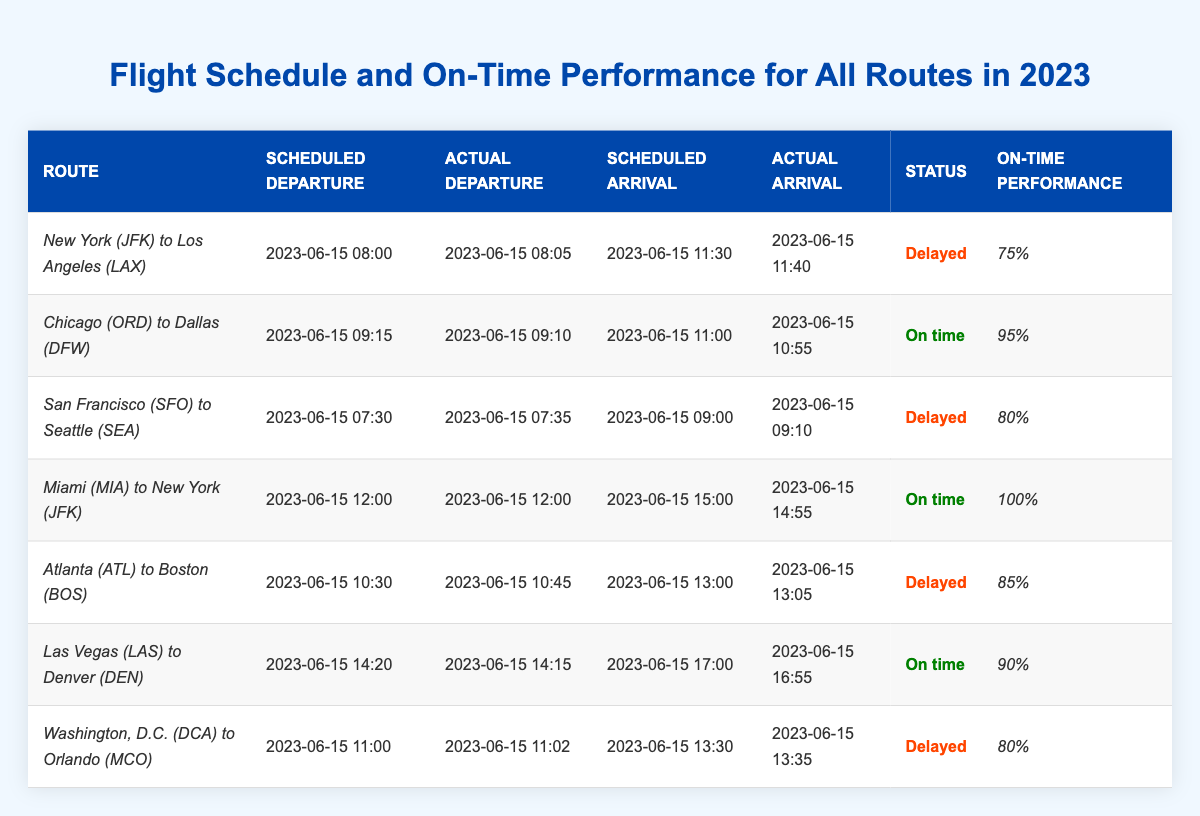What is the on-time performance percentage for the flight from Miami to New York? The on-time performance percentage for the flight from Miami (MIA) to New York (JFK) is listed in the table as 100%.
Answer: 100% Which flight had the highest on-time performance? The flight from Miami (MIA) to New York (JFK) had the highest on-time performance at 100%.
Answer: Miami to New York How many flights were delayed? By reviewing the status column in the table, four flights are marked as delayed: New York to Los Angeles, San Francisco to Seattle, Atlanta to Boston, and Washington, D.C. to Orlando.
Answer: 4 What were the scheduled departure times for the delayed flights? The scheduled departure times for the delayed flights are as follows: New York to Los Angeles at 08:00, San Francisco to Seattle at 07:30, Atlanta to Boston at 10:30, and Washington, D.C. to Orlando at 11:00.
Answer: 08:00, 07:30, 10:30, 11:00 Is there any flight that departed on time and arrived early? Yes, the flight from Miami (MIA) to New York (JFK) departed on time and arrived early at 14:55, ahead of the scheduled arrival time of 15:00.
Answer: Yes What is the average on-time performance percentage for all flights listed? To calculate the average, we add the on-time performance percentages: (75 + 95 + 80 + 100 + 85 + 90 + 80) = 705. Then divide by the number of flights (7), which results in an average of 705 / 7 = 100.71%.
Answer: 100.71% Which flight had the latest scheduled arrival time? The flight from New York (JFK) to Los Angeles (LAX) has the latest scheduled arrival time at 11:30 on June 15.
Answer: New York to Los Angeles For which flight was the actual departure later than the scheduled departure? The flights that had an actual departure later than scheduled are New York to Los Angeles, San Francisco to Seattle, Atlanta to Boston, and Washington, D.C. to Orlando.
Answer: 4 flights What was the status of the flight from Las Vegas to Denver? The flight from Las Vegas (LAS) to Denver (DEN) is marked as "On time" in the status column.
Answer: On time Which route had an actual arrival time after the scheduled arrival time? The flights from New York (JFK) to Los Angeles (LAX), San Francisco (SFO) to Seattle (SEA), Atlanta (ATL) to Boston (BOS), and Washington, D.C. (DCA) to Orlando (MCO) all had actual arrival times later than scheduled.
Answer: 4 routes 